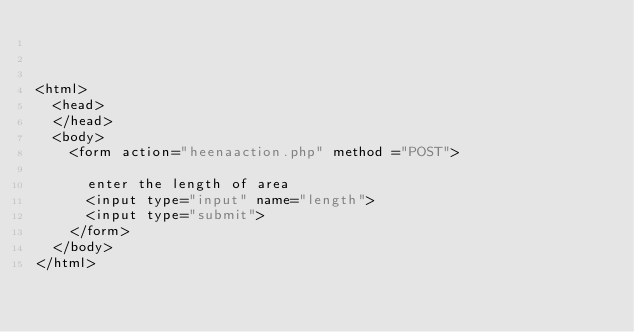Convert code to text. <code><loc_0><loc_0><loc_500><loc_500><_PHP_>


<html>
	<head>
	</head>
	<body>
		<form action="heenaaction.php" method ="POST">

			enter the length of area
			<input type="input" name="length">
			<input type="submit">
		</form> 
	</body>
</html>
	</code> 